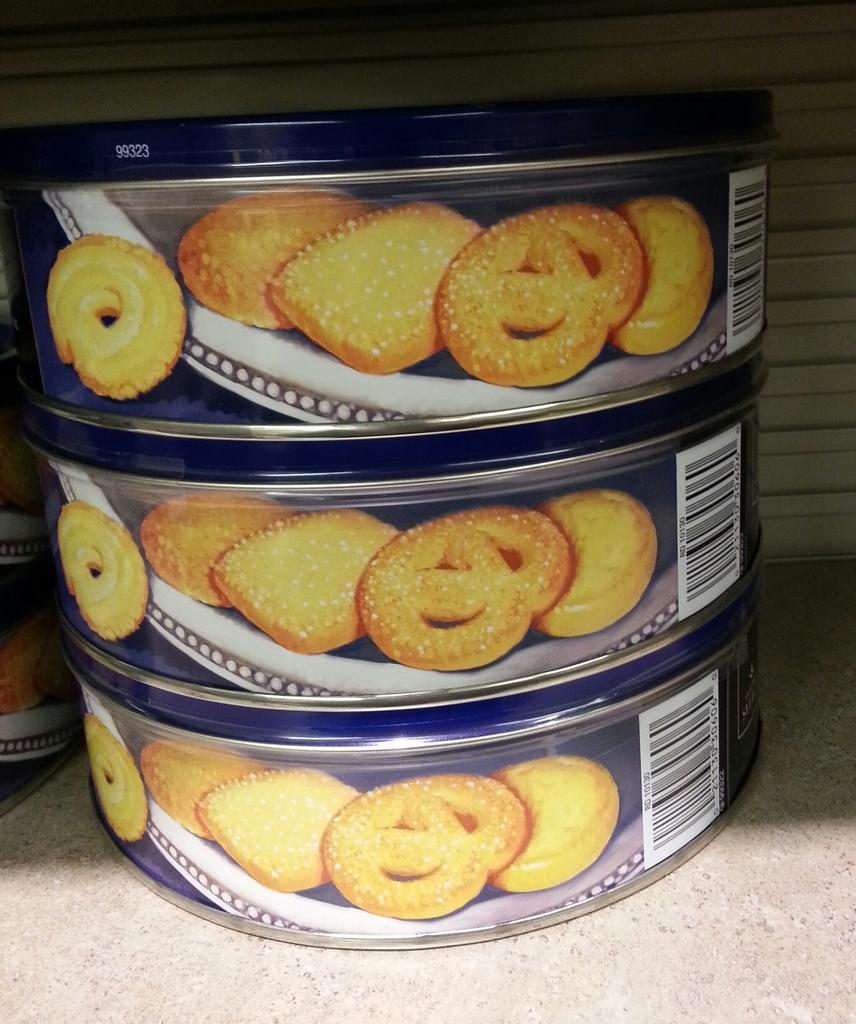Can you describe this image briefly? In the image there are three cookie boxes one above other on table, behind it there is wall. 